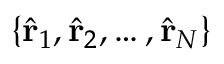Convert formula to latex. <formula><loc_0><loc_0><loc_500><loc_500>\{ \hat { r } _ { 1 } , \hat { r } _ { 2 } , \hdots , \hat { r } _ { N } \}</formula> 